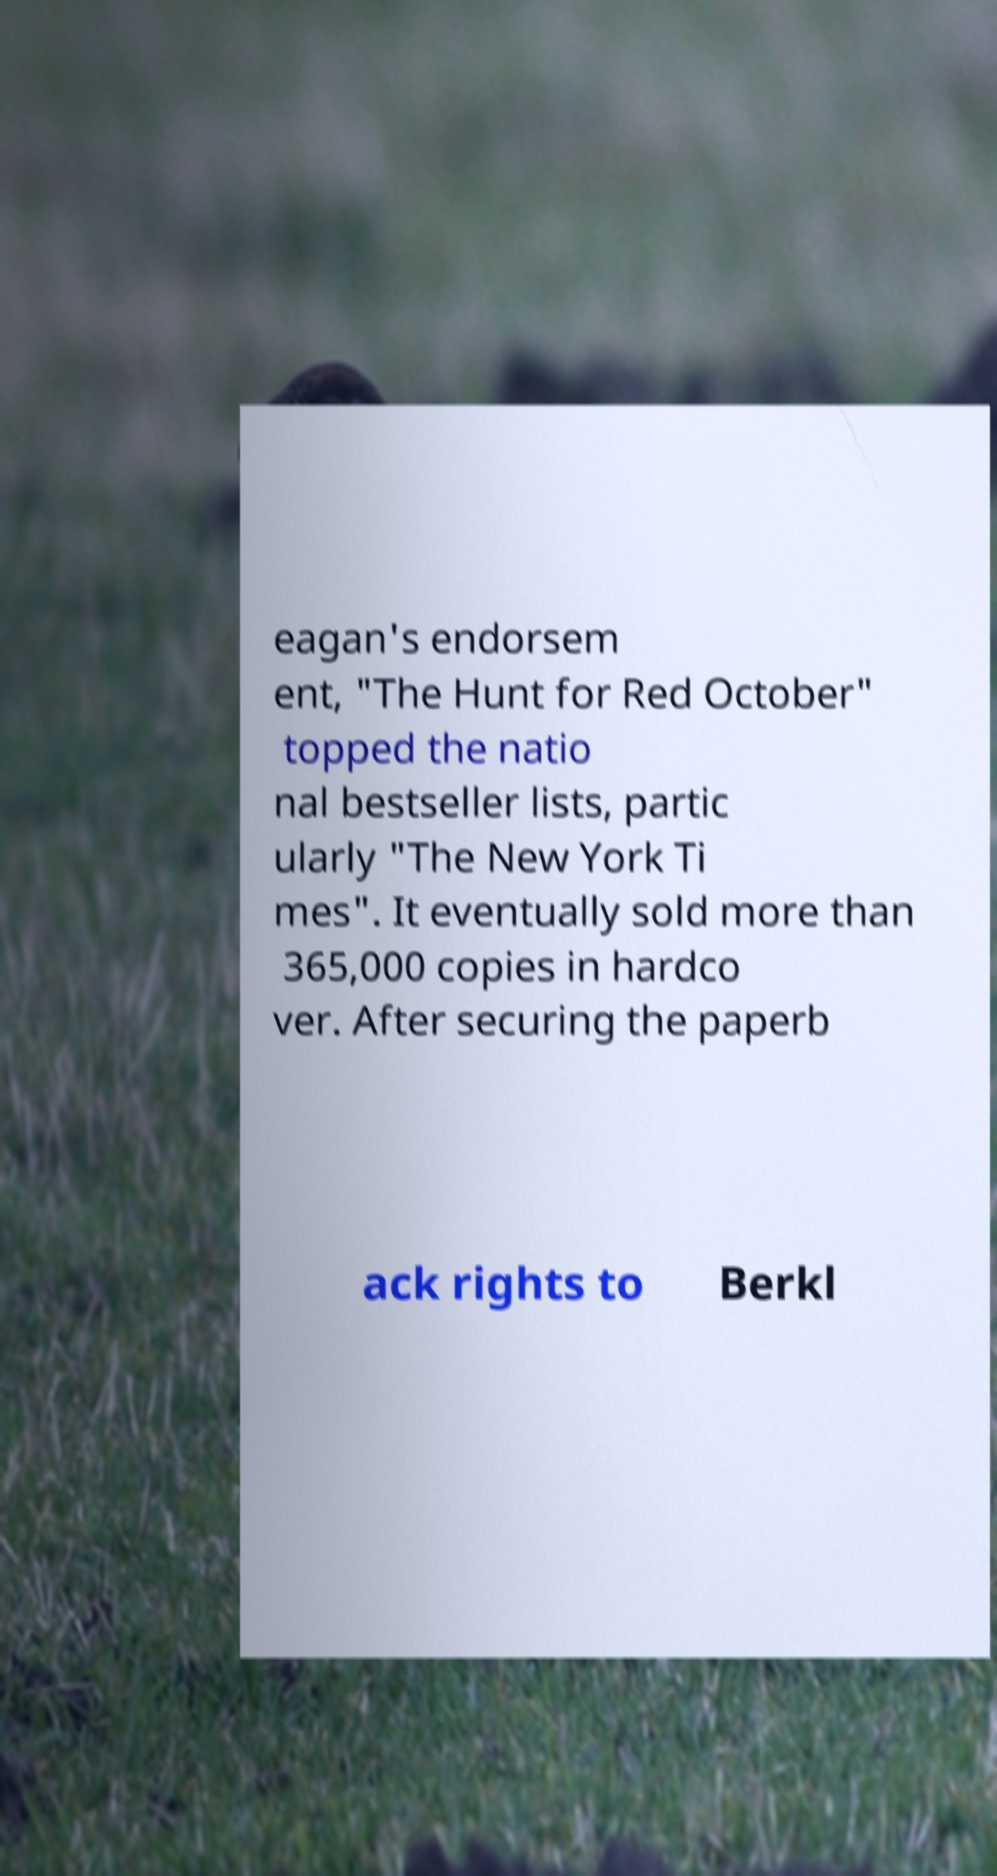For documentation purposes, I need the text within this image transcribed. Could you provide that? eagan's endorsem ent, "The Hunt for Red October" topped the natio nal bestseller lists, partic ularly "The New York Ti mes". It eventually sold more than 365,000 copies in hardco ver. After securing the paperb ack rights to Berkl 